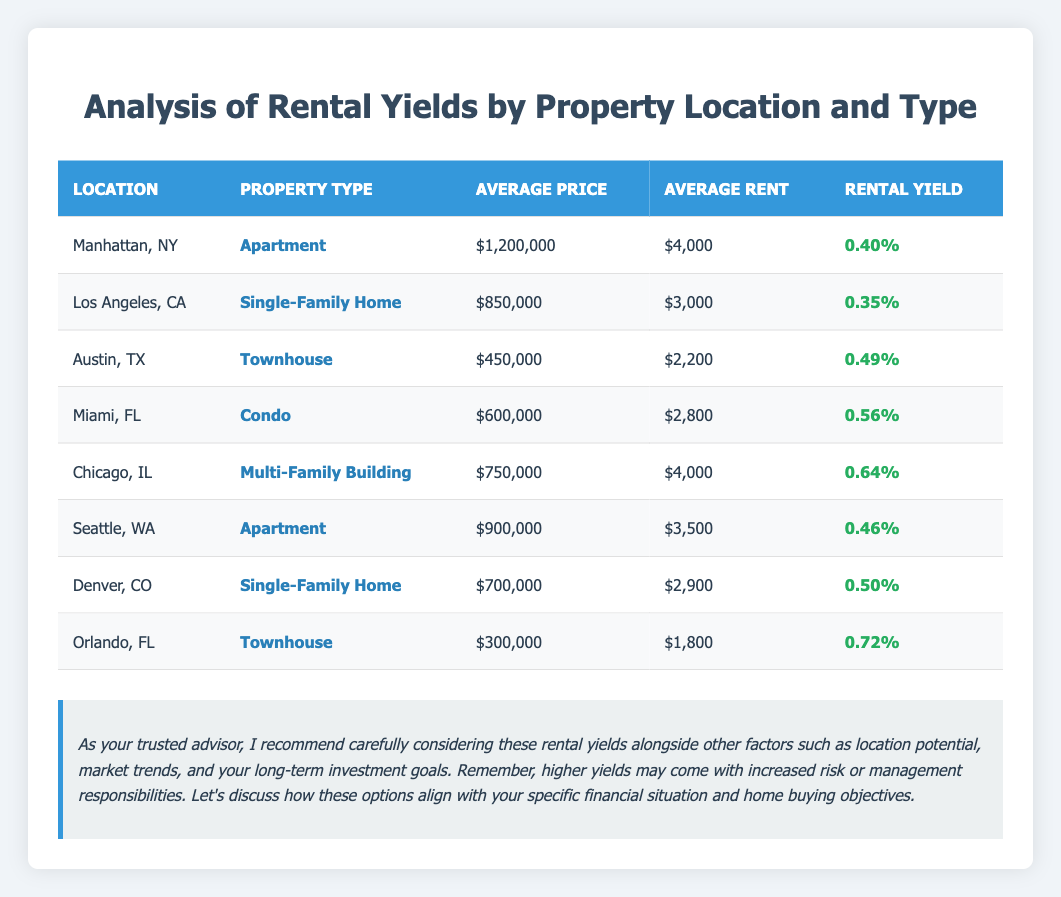What is the rental yield for an apartment in Manhattan, NY? The rental yield for an apartment in Manhattan, NY is directly referenced in the table under the column "Rental Yield," which indicates a value of 0.40.
Answer: 0.40% Which property location has the highest rental yield? To find the highest rental yield, I can look at the rental yield values for each property location in the table. The maximum value is 0.72, found in Orlando, FL.
Answer: Orlando, FL How does the average rent of a townhouse in Austin, TX compare to that in Orlando, FL? The average rent for a townhouse in Austin, TX is $2,200, while for Orlando, FL it is $1,800. Comparing these values shows that Austin, TX has a higher average rent by $400.
Answer: $400 Is the average price of a condo in Miami, FL higher than that of a multi-family building in Chicago, IL? The average price for a condo in Miami, FL is $600,000, and for a multi-family building in Chicago, IL, it is $750,000. Since $600,000 is less than $750,000, the statement is false.
Answer: No What is the difference in average rent between the multi-family building in Chicago, IL and the townhouse in Orlando, FL? The average rent for the multi-family building in Chicago is $4,000, while the townhouse in Orlando has an average rent of $1,800. The difference is calculated as $4,000 - $1,800 = $2,200.
Answer: $2,200 Are there any property types in the table that have a rental yield greater than 0.50? By checking the rental yield values, I find that the multi-family building in Chicago, IL (0.64), the condo in Miami, FL (0.56), and the townhouse in Orlando, FL (0.72) all have yields greater than 0.50. Therefore, the answer is yes.
Answer: Yes What is the average rental yield of the two single-family home entries listed? The rental yield for the single-family home in Los Angeles, CA is 0.35 and for Denver, CO is 0.50. To find the average, I add them together (0.35 + 0.50 = 0.85) and then divide by 2 (0.85 / 2 = 0.425).
Answer: 0.425 Which property type has the lowest average price, and what is that price? By reviewing the average prices listed, I find the townhouse in Orlando, FL has the lowest average price at $300,000.
Answer: $300,000 How does the average price of an apartment in Seattle, WA compare to that in Manhattan, NY? The average price for an apartment in Seattle, WA is $900,000, while in Manhattan, NY, it is $1,200,000. Comparing these prices shows Seattle's is lower by $300,000.
Answer: $300,000 